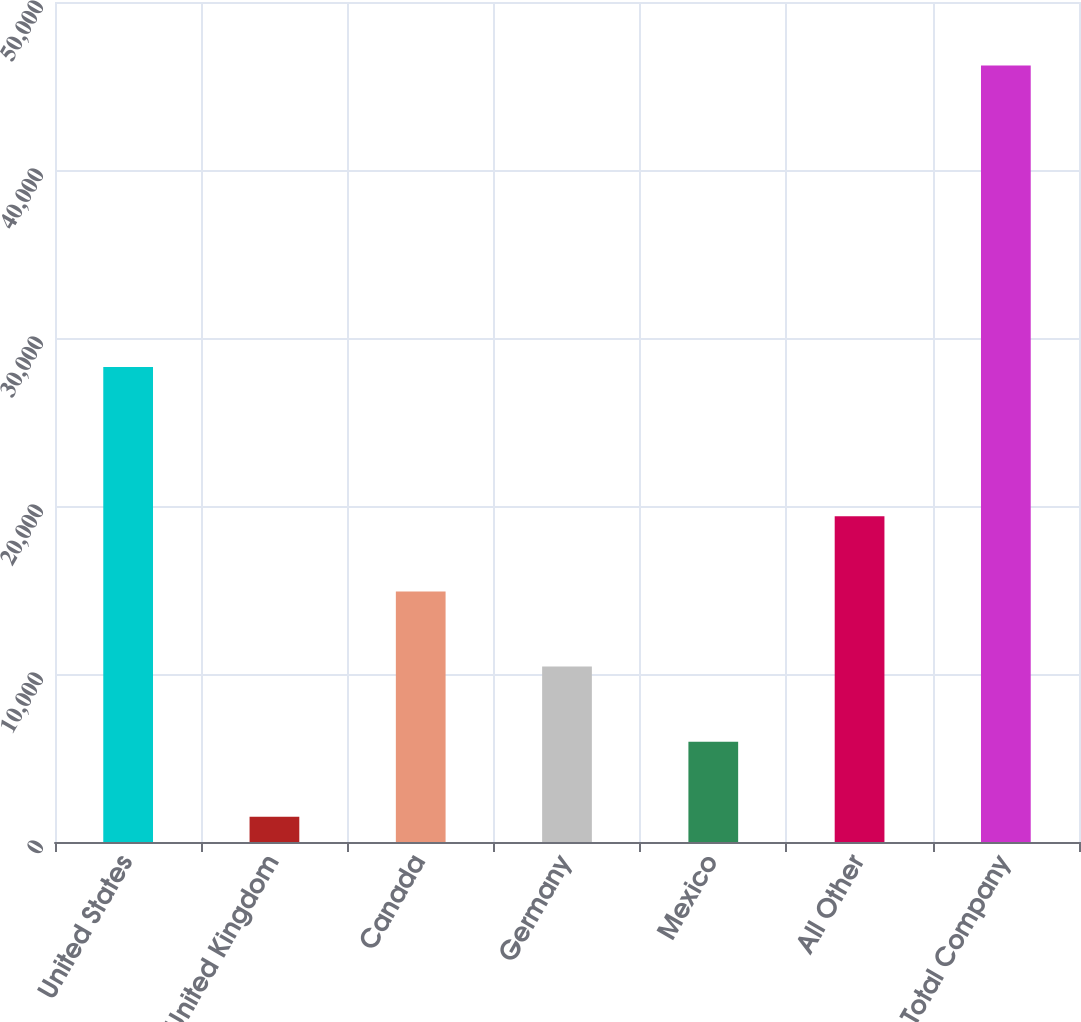Convert chart. <chart><loc_0><loc_0><loc_500><loc_500><bar_chart><fcel>United States<fcel>United Kingdom<fcel>Canada<fcel>Germany<fcel>Mexico<fcel>All Other<fcel>Total Company<nl><fcel>28276<fcel>1503<fcel>14916.9<fcel>10445.6<fcel>5974.3<fcel>19388.2<fcel>46216<nl></chart> 